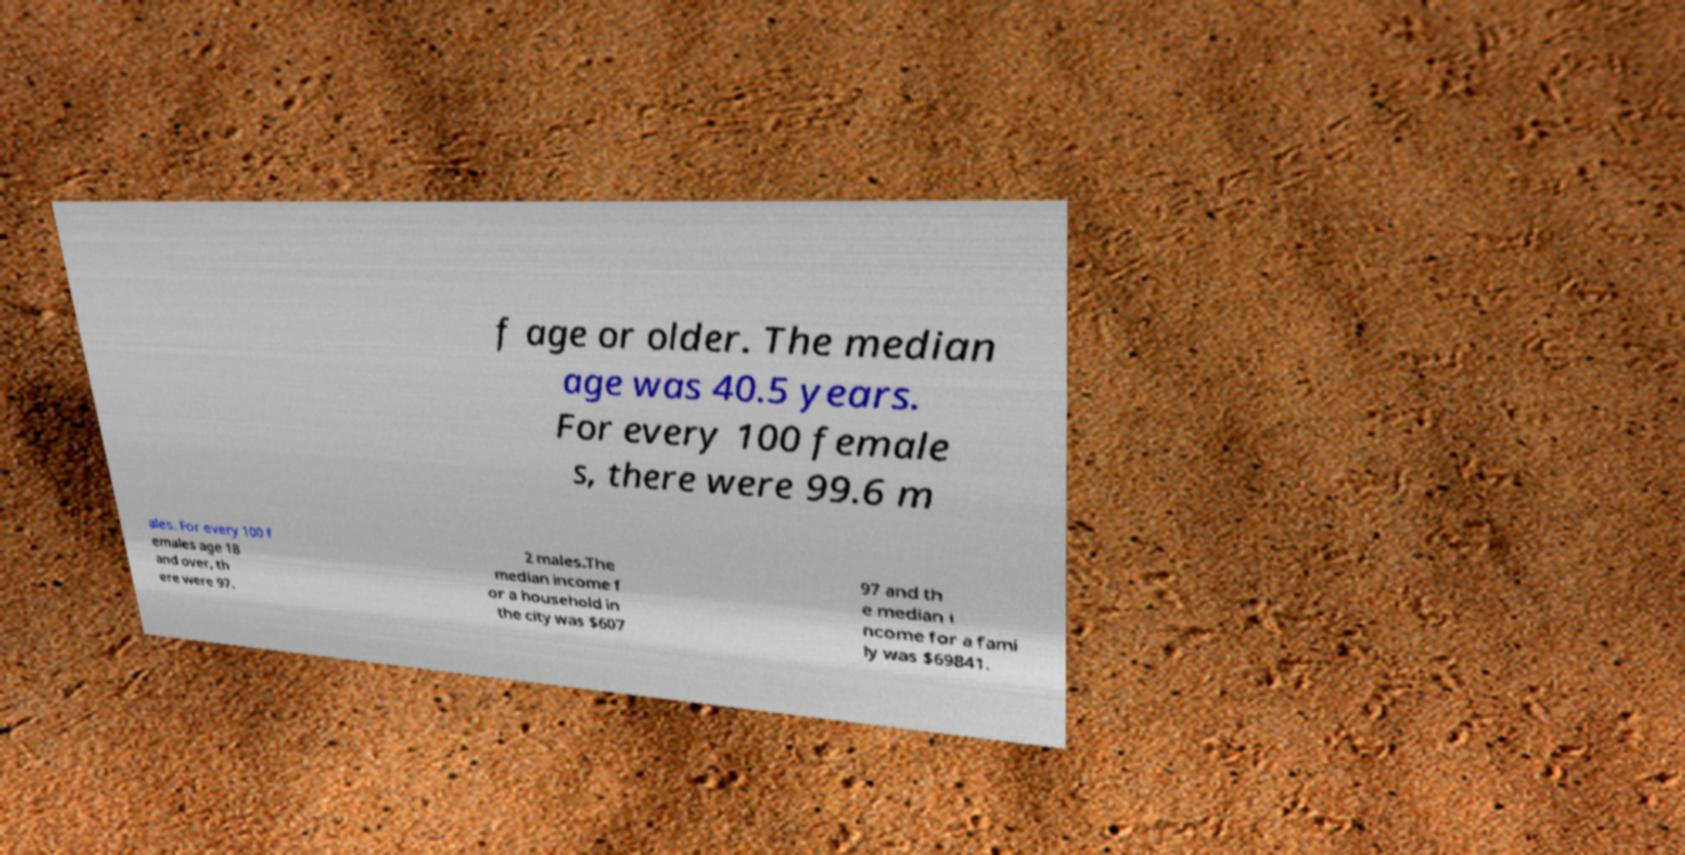For documentation purposes, I need the text within this image transcribed. Could you provide that? f age or older. The median age was 40.5 years. For every 100 female s, there were 99.6 m ales. For every 100 f emales age 18 and over, th ere were 97. 2 males.The median income f or a household in the city was $607 97 and th e median i ncome for a fami ly was $69841. 